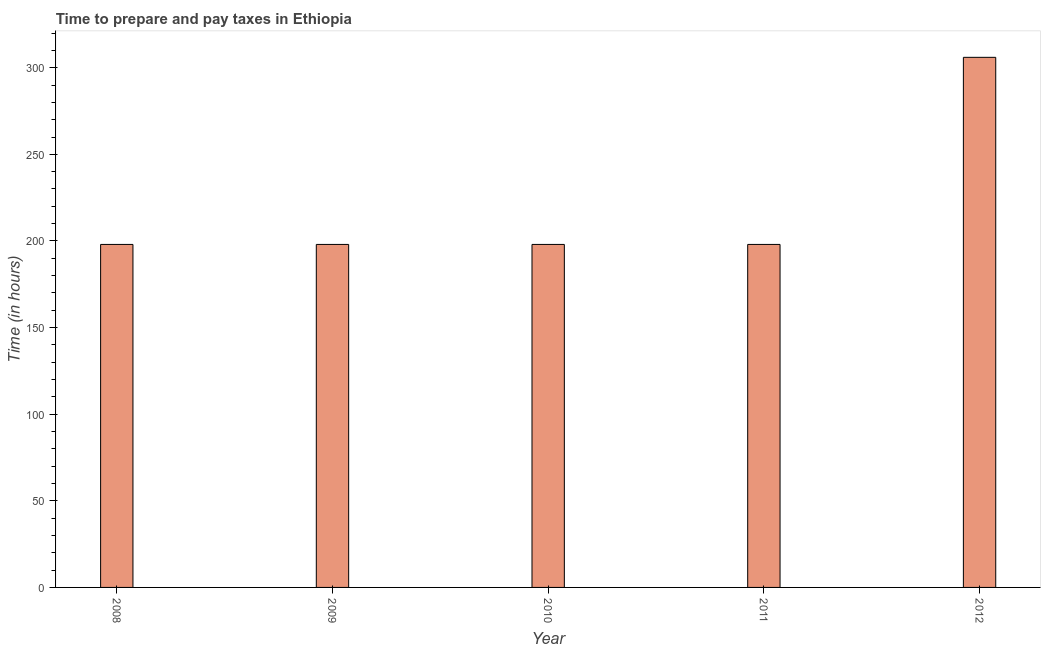Does the graph contain any zero values?
Give a very brief answer. No. What is the title of the graph?
Give a very brief answer. Time to prepare and pay taxes in Ethiopia. What is the label or title of the X-axis?
Provide a short and direct response. Year. What is the label or title of the Y-axis?
Your answer should be very brief. Time (in hours). What is the time to prepare and pay taxes in 2008?
Make the answer very short. 198. Across all years, what is the maximum time to prepare and pay taxes?
Offer a terse response. 306. Across all years, what is the minimum time to prepare and pay taxes?
Offer a very short reply. 198. What is the sum of the time to prepare and pay taxes?
Ensure brevity in your answer.  1098. What is the difference between the time to prepare and pay taxes in 2009 and 2012?
Your answer should be compact. -108. What is the average time to prepare and pay taxes per year?
Provide a short and direct response. 219. What is the median time to prepare and pay taxes?
Give a very brief answer. 198. In how many years, is the time to prepare and pay taxes greater than 310 hours?
Keep it short and to the point. 0. Do a majority of the years between 2011 and 2012 (inclusive) have time to prepare and pay taxes greater than 170 hours?
Your response must be concise. Yes. What is the ratio of the time to prepare and pay taxes in 2009 to that in 2012?
Keep it short and to the point. 0.65. Is the time to prepare and pay taxes in 2011 less than that in 2012?
Ensure brevity in your answer.  Yes. Is the difference between the time to prepare and pay taxes in 2009 and 2011 greater than the difference between any two years?
Ensure brevity in your answer.  No. What is the difference between the highest and the second highest time to prepare and pay taxes?
Offer a very short reply. 108. Is the sum of the time to prepare and pay taxes in 2011 and 2012 greater than the maximum time to prepare and pay taxes across all years?
Keep it short and to the point. Yes. What is the difference between the highest and the lowest time to prepare and pay taxes?
Provide a short and direct response. 108. How many bars are there?
Give a very brief answer. 5. Are all the bars in the graph horizontal?
Your response must be concise. No. Are the values on the major ticks of Y-axis written in scientific E-notation?
Offer a very short reply. No. What is the Time (in hours) of 2008?
Offer a very short reply. 198. What is the Time (in hours) in 2009?
Your answer should be compact. 198. What is the Time (in hours) of 2010?
Offer a terse response. 198. What is the Time (in hours) of 2011?
Make the answer very short. 198. What is the Time (in hours) in 2012?
Provide a short and direct response. 306. What is the difference between the Time (in hours) in 2008 and 2009?
Your response must be concise. 0. What is the difference between the Time (in hours) in 2008 and 2012?
Provide a short and direct response. -108. What is the difference between the Time (in hours) in 2009 and 2010?
Provide a succinct answer. 0. What is the difference between the Time (in hours) in 2009 and 2011?
Ensure brevity in your answer.  0. What is the difference between the Time (in hours) in 2009 and 2012?
Your answer should be very brief. -108. What is the difference between the Time (in hours) in 2010 and 2012?
Keep it short and to the point. -108. What is the difference between the Time (in hours) in 2011 and 2012?
Provide a succinct answer. -108. What is the ratio of the Time (in hours) in 2008 to that in 2011?
Your answer should be very brief. 1. What is the ratio of the Time (in hours) in 2008 to that in 2012?
Your response must be concise. 0.65. What is the ratio of the Time (in hours) in 2009 to that in 2011?
Give a very brief answer. 1. What is the ratio of the Time (in hours) in 2009 to that in 2012?
Give a very brief answer. 0.65. What is the ratio of the Time (in hours) in 2010 to that in 2011?
Offer a very short reply. 1. What is the ratio of the Time (in hours) in 2010 to that in 2012?
Provide a succinct answer. 0.65. What is the ratio of the Time (in hours) in 2011 to that in 2012?
Provide a succinct answer. 0.65. 